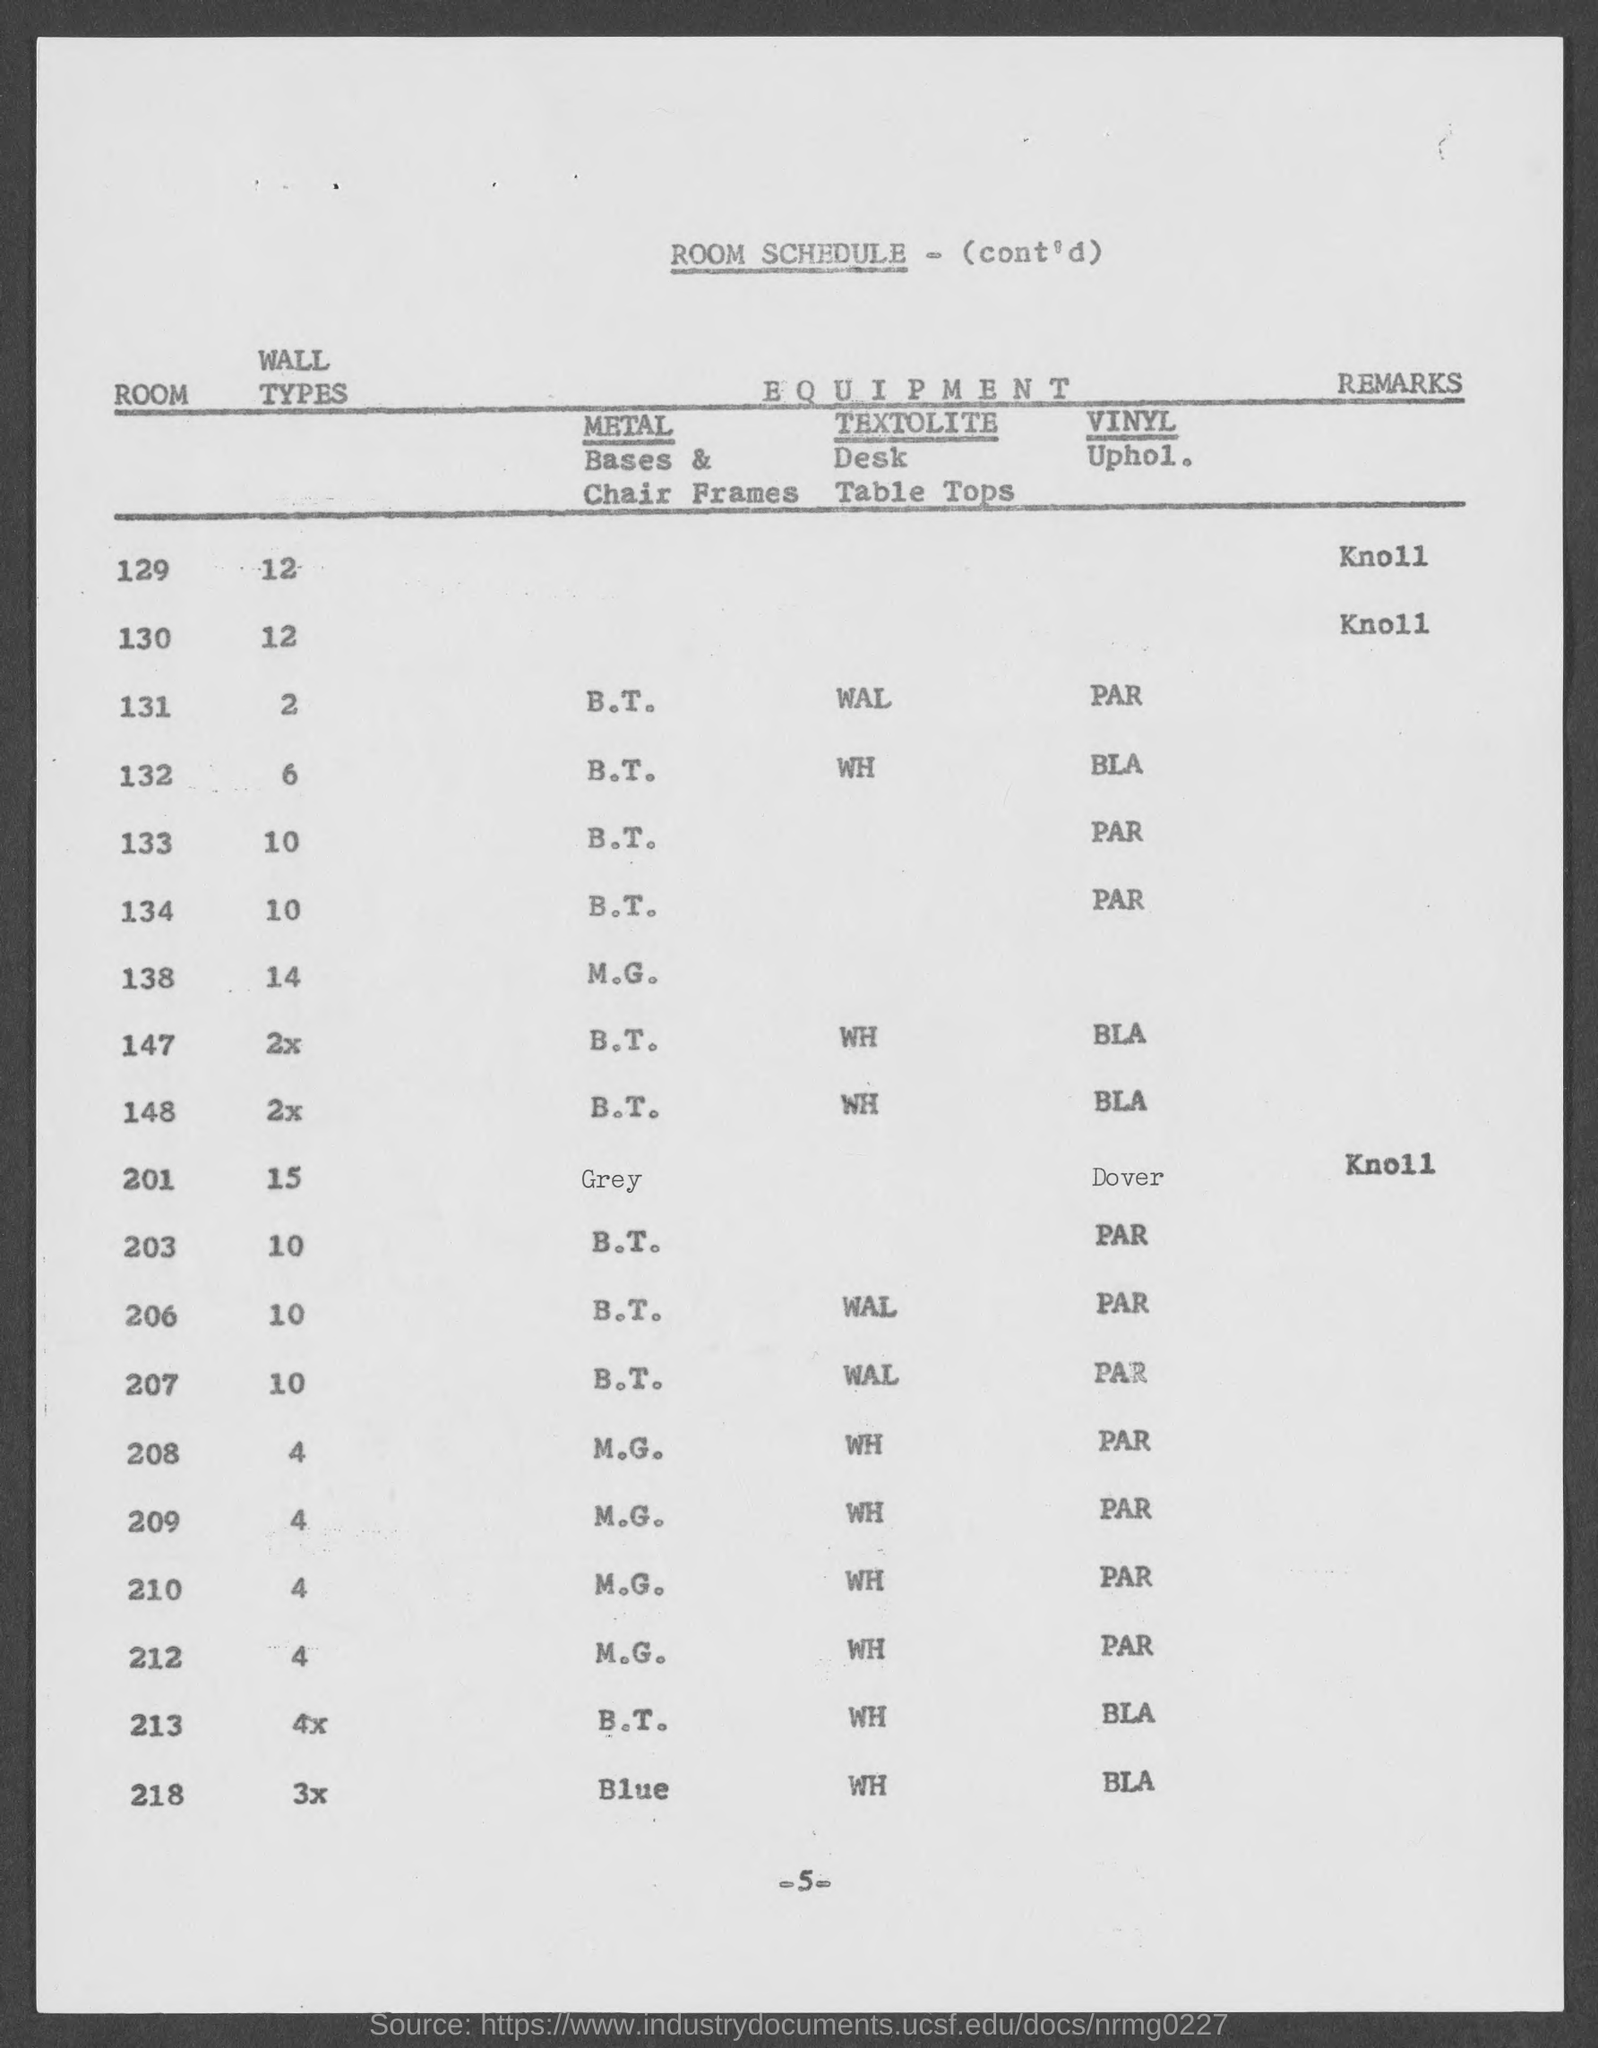Indicate a few pertinent items in this graphic. The wall types in Room 129 are 12.. The types of walls in Room 130 are 12.. The title of the document is 'Room Schedule - (Cont'd)'. The page number is 5 and counting. 